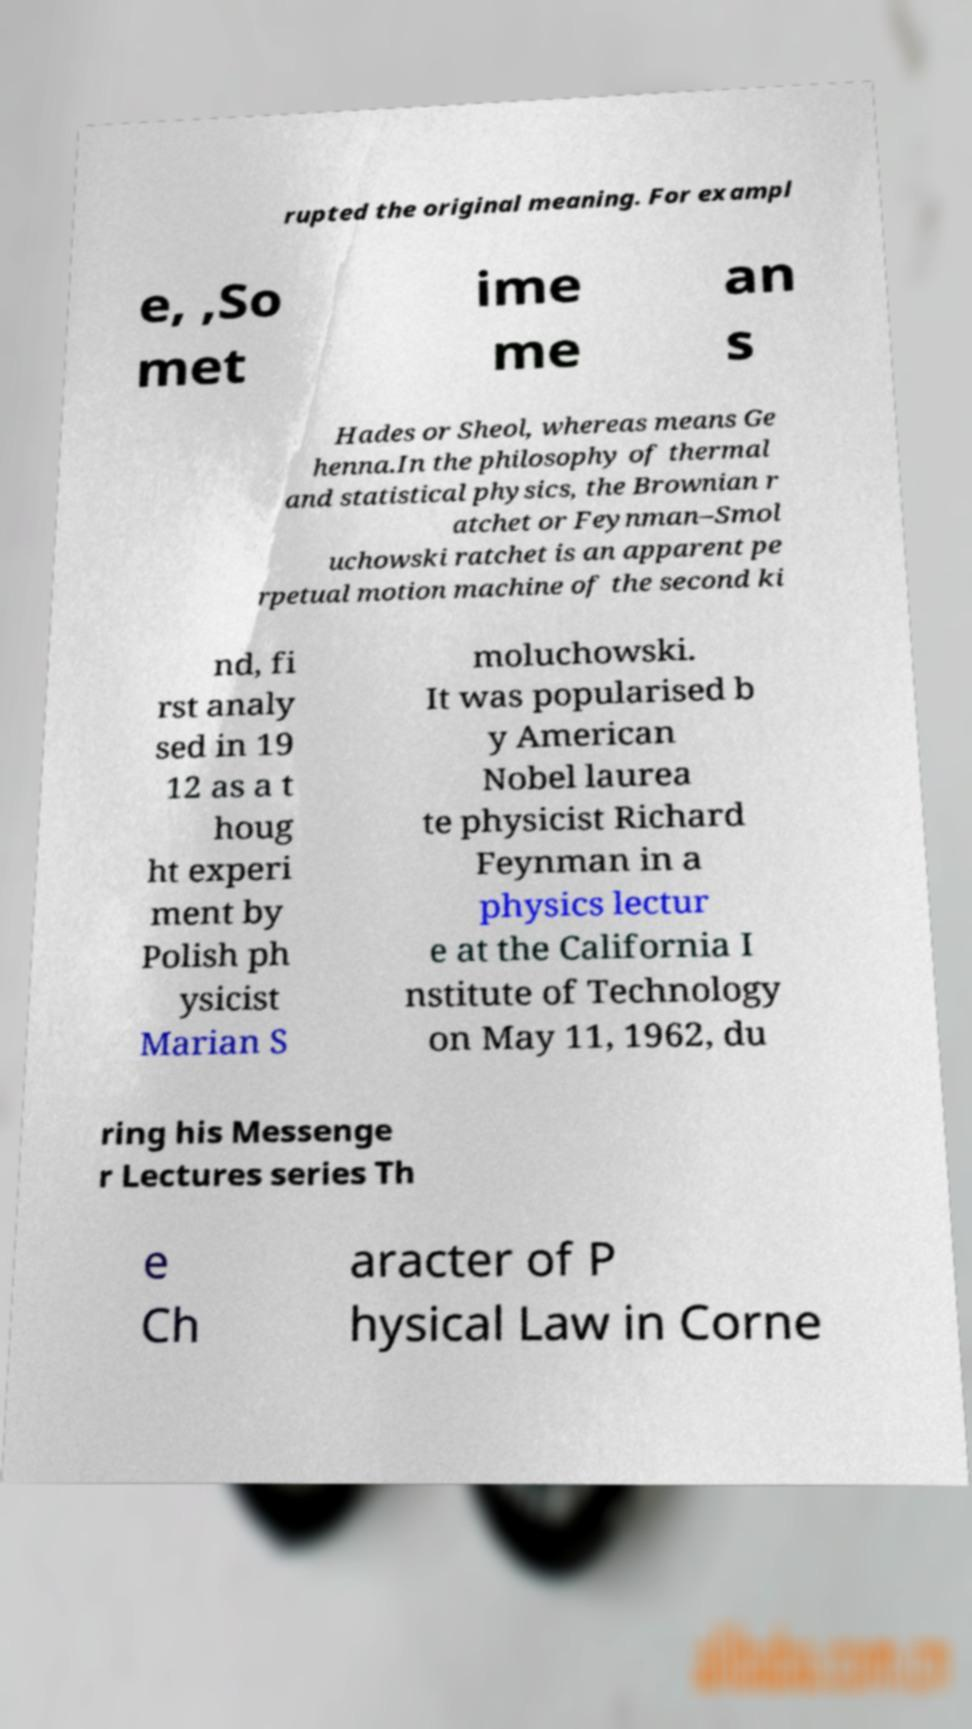Can you accurately transcribe the text from the provided image for me? rupted the original meaning. For exampl e, ,So met ime me an s Hades or Sheol, whereas means Ge henna.In the philosophy of thermal and statistical physics, the Brownian r atchet or Feynman–Smol uchowski ratchet is an apparent pe rpetual motion machine of the second ki nd, fi rst analy sed in 19 12 as a t houg ht experi ment by Polish ph ysicist Marian S moluchowski. It was popularised b y American Nobel laurea te physicist Richard Feynman in a physics lectur e at the California I nstitute of Technology on May 11, 1962, du ring his Messenge r Lectures series Th e Ch aracter of P hysical Law in Corne 